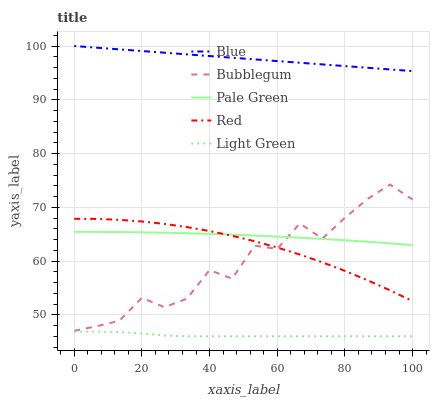Does Light Green have the minimum area under the curve?
Answer yes or no. Yes. Does Blue have the maximum area under the curve?
Answer yes or no. Yes. Does Pale Green have the minimum area under the curve?
Answer yes or no. No. Does Pale Green have the maximum area under the curve?
Answer yes or no. No. Is Blue the smoothest?
Answer yes or no. Yes. Is Bubblegum the roughest?
Answer yes or no. Yes. Is Light Green the smoothest?
Answer yes or no. No. Is Light Green the roughest?
Answer yes or no. No. Does Pale Green have the lowest value?
Answer yes or no. No. Does Blue have the highest value?
Answer yes or no. Yes. Does Pale Green have the highest value?
Answer yes or no. No. Is Light Green less than Pale Green?
Answer yes or no. Yes. Is Red greater than Light Green?
Answer yes or no. Yes. Does Red intersect Pale Green?
Answer yes or no. Yes. Is Red less than Pale Green?
Answer yes or no. No. Is Red greater than Pale Green?
Answer yes or no. No. Does Light Green intersect Pale Green?
Answer yes or no. No. 